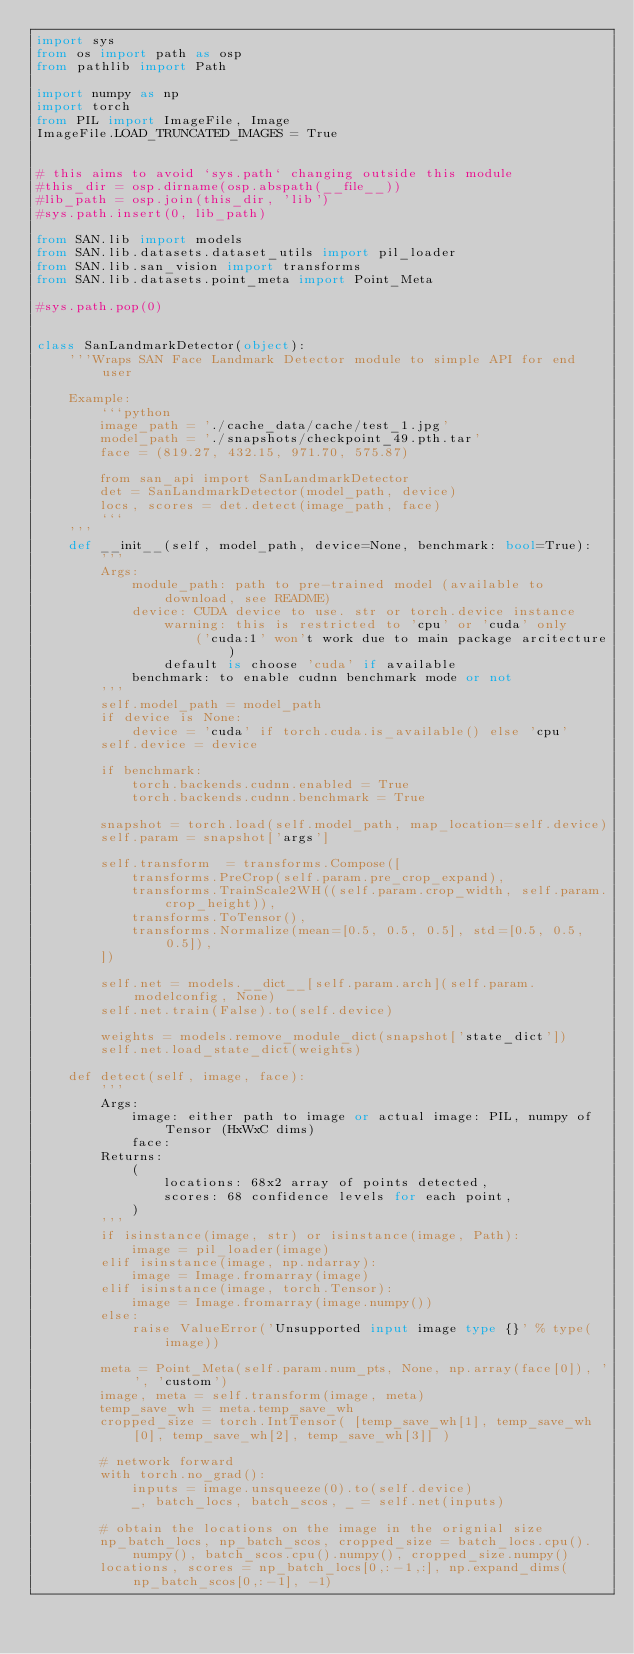<code> <loc_0><loc_0><loc_500><loc_500><_Python_>import sys
from os import path as osp
from pathlib import Path

import numpy as np
import torch
from PIL import ImageFile, Image
ImageFile.LOAD_TRUNCATED_IMAGES = True


# this aims to avoid `sys.path` changing outside this module
#this_dir = osp.dirname(osp.abspath(__file__))
#lib_path = osp.join(this_dir, 'lib')
#sys.path.insert(0, lib_path)

from SAN.lib import models
from SAN.lib.datasets.dataset_utils import pil_loader
from SAN.lib.san_vision import transforms
from SAN.lib.datasets.point_meta import Point_Meta

#sys.path.pop(0)


class SanLandmarkDetector(object):
    '''Wraps SAN Face Landmark Detector module to simple API for end user

    Example:
        ```python
        image_path = './cache_data/cache/test_1.jpg'
        model_path = './snapshots/checkpoint_49.pth.tar'
        face = (819.27, 432.15, 971.70, 575.87)

        from san_api import SanLandmarkDetector
        det = SanLandmarkDetector(model_path, device)
        locs, scores = det.detect(image_path, face)
        ```
    '''
    def __init__(self, model_path, device=None, benchmark: bool=True):
        '''
        Args:
            module_path: path to pre-trained model (available to download, see README)
            device: CUDA device to use. str or torch.device instance
                warning: this is restricted to 'cpu' or 'cuda' only
                    ('cuda:1' won't work due to main package arcitecture)
                default is choose 'cuda' if available
            benchmark: to enable cudnn benchmark mode or not
        '''
        self.model_path = model_path
        if device is None:
            device = 'cuda' if torch.cuda.is_available() else 'cpu'
        self.device = device

        if benchmark:
            torch.backends.cudnn.enabled = True
            torch.backends.cudnn.benchmark = True

        snapshot = torch.load(self.model_path, map_location=self.device)
        self.param = snapshot['args']

        self.transform  = transforms.Compose([
            transforms.PreCrop(self.param.pre_crop_expand),
            transforms.TrainScale2WH((self.param.crop_width, self.param.crop_height)),
            transforms.ToTensor(),
            transforms.Normalize(mean=[0.5, 0.5, 0.5], std=[0.5, 0.5, 0.5]),
        ])

        self.net = models.__dict__[self.param.arch](self.param.modelconfig, None)
        self.net.train(False).to(self.device)

        weights = models.remove_module_dict(snapshot['state_dict'])
        self.net.load_state_dict(weights)

    def detect(self, image, face):
        '''
        Args:
            image: either path to image or actual image: PIL, numpy of Tensor (HxWxC dims)
            face: 
        Returns:
            (
                locations: 68x2 array of points detected,
                scores: 68 confidence levels for each point,
            )
        '''
        if isinstance(image, str) or isinstance(image, Path):
            image = pil_loader(image)
        elif isinstance(image, np.ndarray):
            image = Image.fromarray(image)
        elif isinstance(image, torch.Tensor):
            image = Image.fromarray(image.numpy())
        else:
            raise ValueError('Unsupported input image type {}' % type(image))

        meta = Point_Meta(self.param.num_pts, None, np.array(face[0]), '', 'custom')
        image, meta = self.transform(image, meta)
        temp_save_wh = meta.temp_save_wh
        cropped_size = torch.IntTensor( [temp_save_wh[1], temp_save_wh[0], temp_save_wh[2], temp_save_wh[3]] )

        # network forward
        with torch.no_grad():
            inputs = image.unsqueeze(0).to(self.device)
            _, batch_locs, batch_scos, _ = self.net(inputs)

        # obtain the locations on the image in the orignial size
        np_batch_locs, np_batch_scos, cropped_size = batch_locs.cpu().numpy(), batch_scos.cpu().numpy(), cropped_size.numpy()
        locations, scores = np_batch_locs[0,:-1,:], np.expand_dims(np_batch_scos[0,:-1], -1)
</code> 